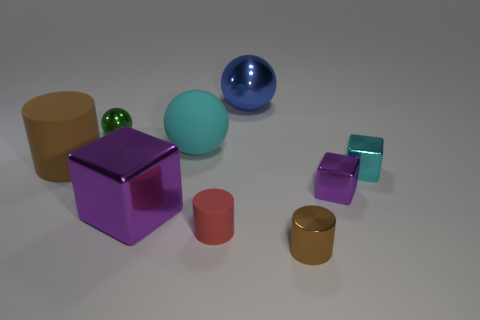The brown thing that is in front of the brown rubber cylinder has what shape? The object in front of the brown rubber cylinder is also a cylinder with a shorter height, known as a disc or puck shape. It has a flat circular top and bottom with a curved side surface. 